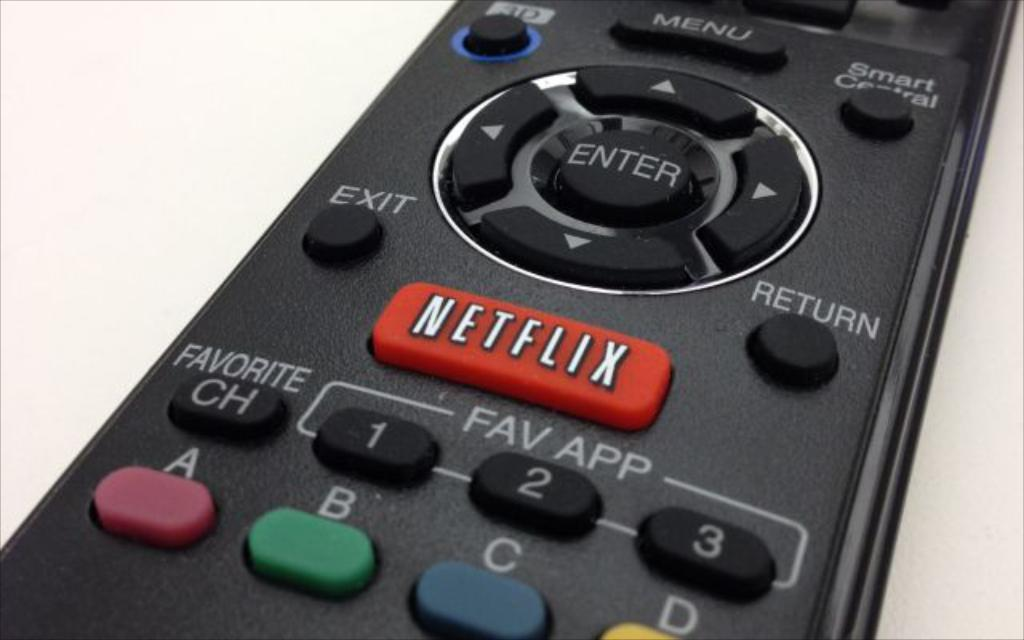<image>
Render a clear and concise summary of the photo. A remote control with A, B, C buttons as well as a Netflix button. 